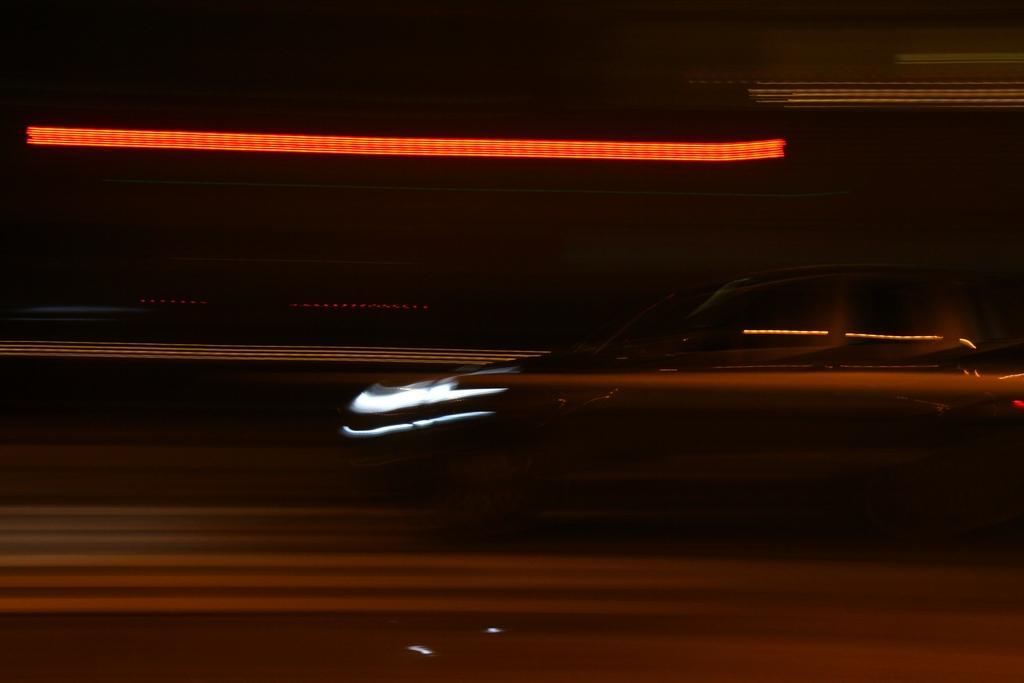Describe this image in one or two sentences. In this image I can see there is a car on a road with dark background. 